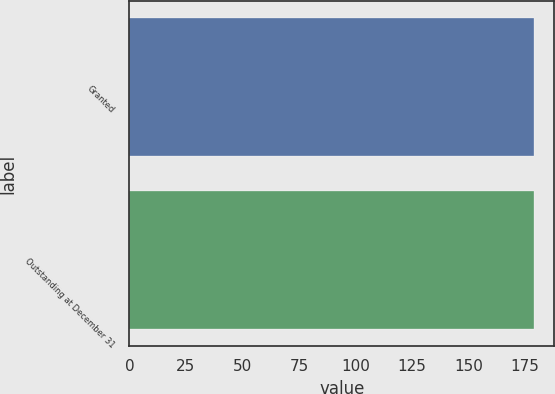Convert chart to OTSL. <chart><loc_0><loc_0><loc_500><loc_500><bar_chart><fcel>Granted<fcel>Outstanding at December 31<nl><fcel>178.84<fcel>178.94<nl></chart> 